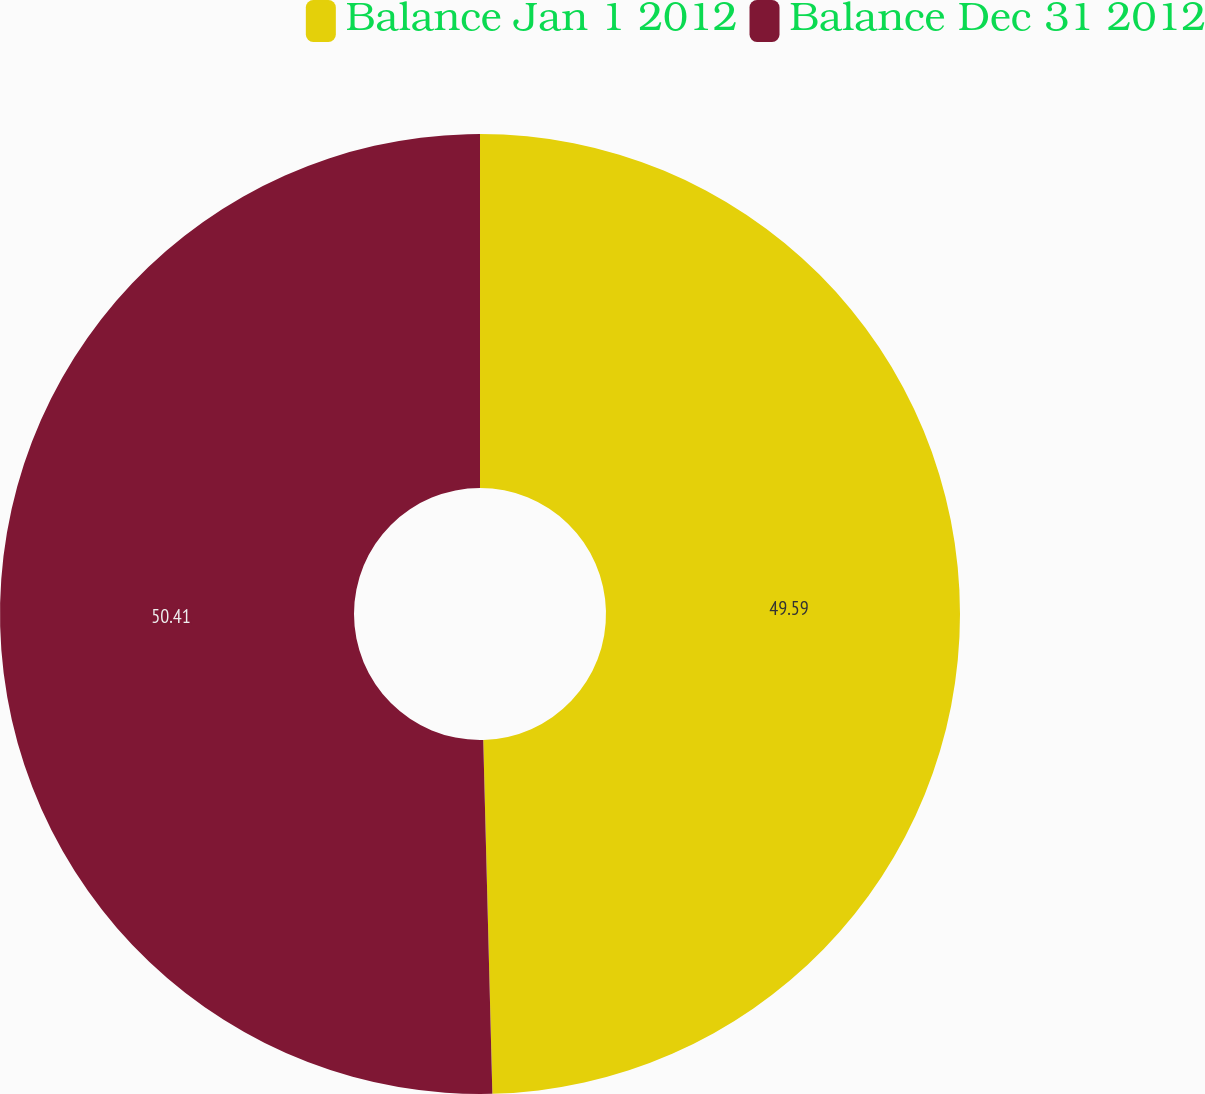Convert chart. <chart><loc_0><loc_0><loc_500><loc_500><pie_chart><fcel>Balance Jan 1 2012<fcel>Balance Dec 31 2012<nl><fcel>49.59%<fcel>50.41%<nl></chart> 